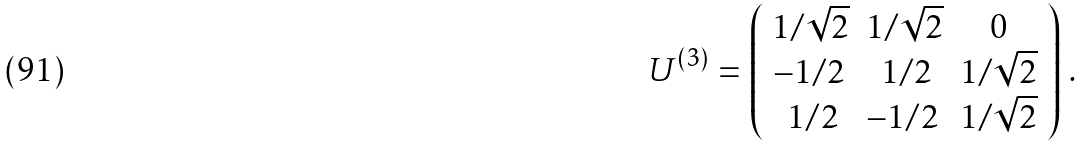<formula> <loc_0><loc_0><loc_500><loc_500>U ^ { ( 3 ) } = \left ( \begin{array} { c c c } 1 / \sqrt { 2 } & 1 / \sqrt { 2 } & 0 \\ - 1 / { 2 } \, & \, 1 / 2 & 1 / \sqrt { 2 } \\ \, 1 / 2 & - 1 / 2 \, & 1 / \sqrt { 2 } \end{array} \right ) \, .</formula> 